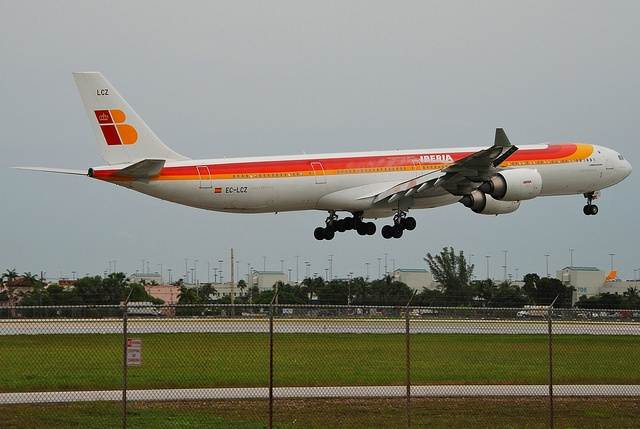Describe the objects in this image and their specific colors. I can see a airplane in darkgray, black, gray, and lightgray tones in this image. 